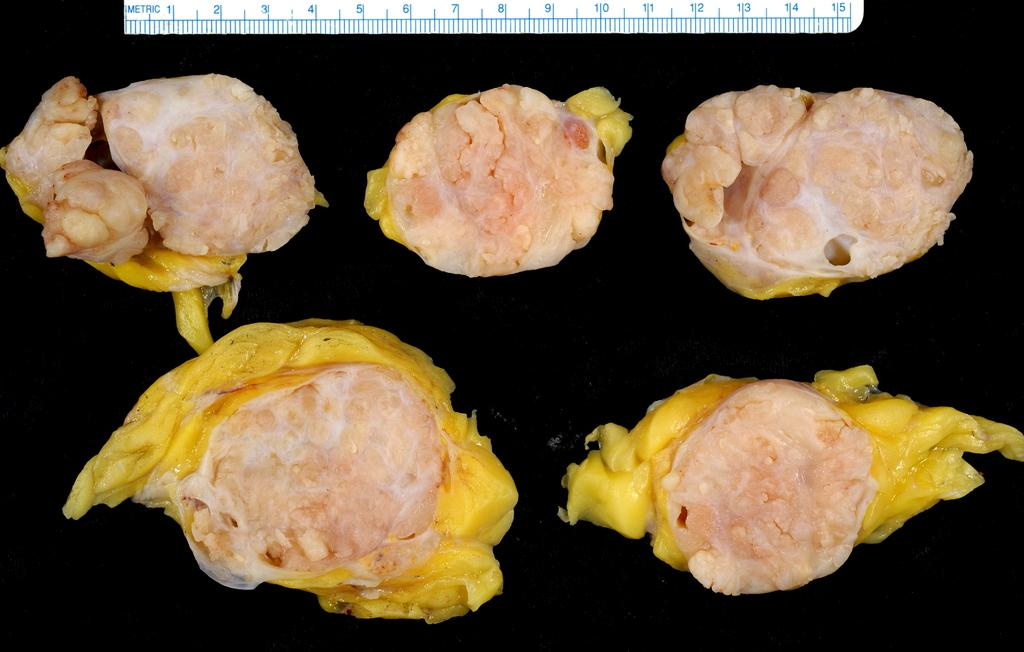What type of food can be seen in the image? There are meat pieces in the image. What color is the background of the image? The background of the image is black. Can you describe any objects or tools in the image? There is a scale at the top of the image. What type of railway is visible in the image? There is no railway present in the image. How many pumps can be seen in the image? There are no pumps visible in the image. 